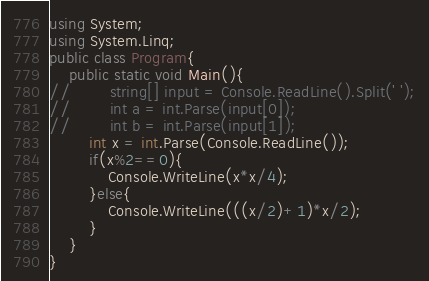<code> <loc_0><loc_0><loc_500><loc_500><_C#_>using System;
using System.Linq;
public class Program{
    public static void Main(){
//        string[] input = Console.ReadLine().Split(' ');
//        int a = int.Parse(input[0]);
//        int b = int.Parse(input[1]);
        int x = int.Parse(Console.ReadLine());
        if(x%2==0){
            Console.WriteLine(x*x/4);
        }else{
            Console.WriteLine(((x/2)+1)*x/2);
        }
    }
}</code> 